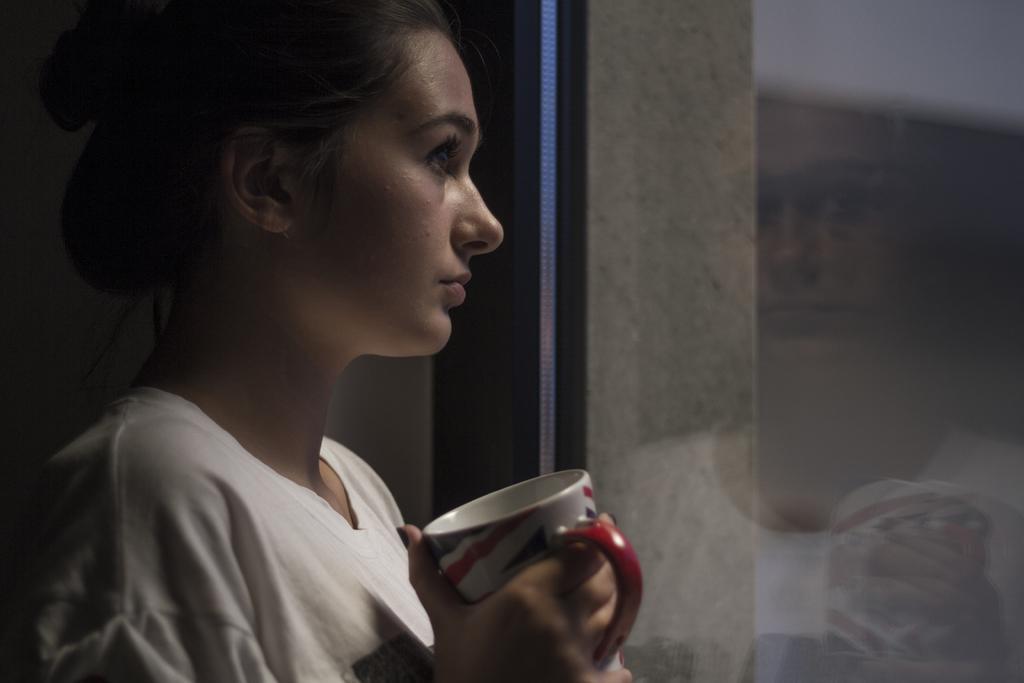Could you give a brief overview of what you see in this image? In this image I can see a woman is holding a cup in her hand and wearing a white color dress. 